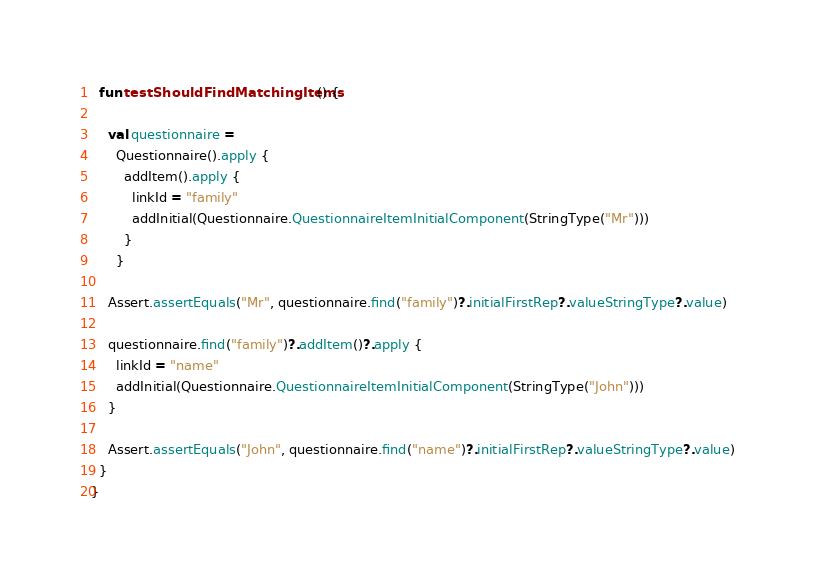<code> <loc_0><loc_0><loc_500><loc_500><_Kotlin_>  fun testShouldFindMatchingItems() {

    val questionnaire =
      Questionnaire().apply {
        addItem().apply {
          linkId = "family"
          addInitial(Questionnaire.QuestionnaireItemInitialComponent(StringType("Mr")))
        }
      }

    Assert.assertEquals("Mr", questionnaire.find("family")?.initialFirstRep?.valueStringType?.value)

    questionnaire.find("family")?.addItem()?.apply {
      linkId = "name"
      addInitial(Questionnaire.QuestionnaireItemInitialComponent(StringType("John")))
    }

    Assert.assertEquals("John", questionnaire.find("name")?.initialFirstRep?.valueStringType?.value)
  }
}
</code> 